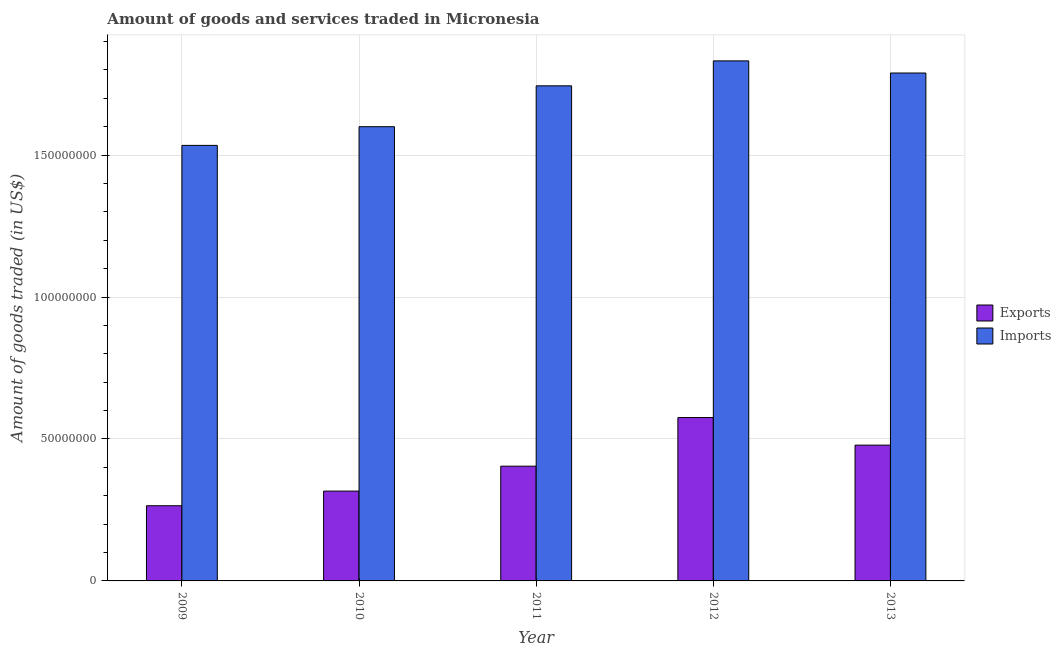Are the number of bars per tick equal to the number of legend labels?
Provide a short and direct response. Yes. Are the number of bars on each tick of the X-axis equal?
Offer a terse response. Yes. How many bars are there on the 5th tick from the left?
Provide a succinct answer. 2. How many bars are there on the 3rd tick from the right?
Provide a succinct answer. 2. What is the label of the 4th group of bars from the left?
Provide a succinct answer. 2012. What is the amount of goods imported in 2012?
Offer a terse response. 1.83e+08. Across all years, what is the maximum amount of goods imported?
Make the answer very short. 1.83e+08. Across all years, what is the minimum amount of goods exported?
Offer a very short reply. 2.65e+07. What is the total amount of goods imported in the graph?
Offer a very short reply. 8.50e+08. What is the difference between the amount of goods exported in 2011 and that in 2012?
Your answer should be very brief. -1.71e+07. What is the difference between the amount of goods exported in 2011 and the amount of goods imported in 2010?
Your answer should be compact. 8.78e+06. What is the average amount of goods exported per year?
Make the answer very short. 4.08e+07. In the year 2013, what is the difference between the amount of goods imported and amount of goods exported?
Offer a very short reply. 0. In how many years, is the amount of goods imported greater than 100000000 US$?
Ensure brevity in your answer.  5. What is the ratio of the amount of goods exported in 2009 to that in 2011?
Offer a terse response. 0.66. Is the amount of goods imported in 2012 less than that in 2013?
Your answer should be compact. No. Is the difference between the amount of goods exported in 2010 and 2011 greater than the difference between the amount of goods imported in 2010 and 2011?
Offer a very short reply. No. What is the difference between the highest and the second highest amount of goods imported?
Make the answer very short. 4.27e+06. What is the difference between the highest and the lowest amount of goods exported?
Offer a very short reply. 3.11e+07. Is the sum of the amount of goods imported in 2011 and 2013 greater than the maximum amount of goods exported across all years?
Ensure brevity in your answer.  Yes. What does the 2nd bar from the left in 2009 represents?
Your answer should be very brief. Imports. What does the 1st bar from the right in 2013 represents?
Offer a terse response. Imports. How many bars are there?
Provide a succinct answer. 10. How many years are there in the graph?
Give a very brief answer. 5. What is the difference between two consecutive major ticks on the Y-axis?
Give a very brief answer. 5.00e+07. Are the values on the major ticks of Y-axis written in scientific E-notation?
Provide a short and direct response. No. Does the graph contain any zero values?
Ensure brevity in your answer.  No. How are the legend labels stacked?
Provide a short and direct response. Vertical. What is the title of the graph?
Offer a terse response. Amount of goods and services traded in Micronesia. Does "Mobile cellular" appear as one of the legend labels in the graph?
Your answer should be very brief. No. What is the label or title of the X-axis?
Ensure brevity in your answer.  Year. What is the label or title of the Y-axis?
Offer a terse response. Amount of goods traded (in US$). What is the Amount of goods traded (in US$) in Exports in 2009?
Offer a very short reply. 2.65e+07. What is the Amount of goods traded (in US$) in Imports in 2009?
Offer a very short reply. 1.53e+08. What is the Amount of goods traded (in US$) of Exports in 2010?
Make the answer very short. 3.16e+07. What is the Amount of goods traded (in US$) of Imports in 2010?
Provide a short and direct response. 1.60e+08. What is the Amount of goods traded (in US$) of Exports in 2011?
Offer a very short reply. 4.04e+07. What is the Amount of goods traded (in US$) of Imports in 2011?
Give a very brief answer. 1.74e+08. What is the Amount of goods traded (in US$) of Exports in 2012?
Keep it short and to the point. 5.76e+07. What is the Amount of goods traded (in US$) in Imports in 2012?
Provide a short and direct response. 1.83e+08. What is the Amount of goods traded (in US$) in Exports in 2013?
Ensure brevity in your answer.  4.78e+07. What is the Amount of goods traded (in US$) of Imports in 2013?
Provide a short and direct response. 1.79e+08. Across all years, what is the maximum Amount of goods traded (in US$) of Exports?
Give a very brief answer. 5.76e+07. Across all years, what is the maximum Amount of goods traded (in US$) in Imports?
Ensure brevity in your answer.  1.83e+08. Across all years, what is the minimum Amount of goods traded (in US$) in Exports?
Offer a very short reply. 2.65e+07. Across all years, what is the minimum Amount of goods traded (in US$) of Imports?
Offer a very short reply. 1.53e+08. What is the total Amount of goods traded (in US$) in Exports in the graph?
Offer a terse response. 2.04e+08. What is the total Amount of goods traded (in US$) in Imports in the graph?
Provide a succinct answer. 8.50e+08. What is the difference between the Amount of goods traded (in US$) in Exports in 2009 and that in 2010?
Your answer should be very brief. -5.16e+06. What is the difference between the Amount of goods traded (in US$) in Imports in 2009 and that in 2010?
Provide a short and direct response. -6.59e+06. What is the difference between the Amount of goods traded (in US$) in Exports in 2009 and that in 2011?
Give a very brief answer. -1.39e+07. What is the difference between the Amount of goods traded (in US$) of Imports in 2009 and that in 2011?
Your answer should be very brief. -2.10e+07. What is the difference between the Amount of goods traded (in US$) in Exports in 2009 and that in 2012?
Ensure brevity in your answer.  -3.11e+07. What is the difference between the Amount of goods traded (in US$) of Imports in 2009 and that in 2012?
Make the answer very short. -2.98e+07. What is the difference between the Amount of goods traded (in US$) in Exports in 2009 and that in 2013?
Offer a terse response. -2.13e+07. What is the difference between the Amount of goods traded (in US$) in Imports in 2009 and that in 2013?
Ensure brevity in your answer.  -2.55e+07. What is the difference between the Amount of goods traded (in US$) in Exports in 2010 and that in 2011?
Provide a short and direct response. -8.78e+06. What is the difference between the Amount of goods traded (in US$) of Imports in 2010 and that in 2011?
Ensure brevity in your answer.  -1.44e+07. What is the difference between the Amount of goods traded (in US$) in Exports in 2010 and that in 2012?
Provide a succinct answer. -2.59e+07. What is the difference between the Amount of goods traded (in US$) in Imports in 2010 and that in 2012?
Keep it short and to the point. -2.32e+07. What is the difference between the Amount of goods traded (in US$) of Exports in 2010 and that in 2013?
Your answer should be compact. -1.62e+07. What is the difference between the Amount of goods traded (in US$) in Imports in 2010 and that in 2013?
Offer a very short reply. -1.89e+07. What is the difference between the Amount of goods traded (in US$) of Exports in 2011 and that in 2012?
Keep it short and to the point. -1.71e+07. What is the difference between the Amount of goods traded (in US$) of Imports in 2011 and that in 2012?
Your answer should be very brief. -8.79e+06. What is the difference between the Amount of goods traded (in US$) of Exports in 2011 and that in 2013?
Give a very brief answer. -7.41e+06. What is the difference between the Amount of goods traded (in US$) in Imports in 2011 and that in 2013?
Your answer should be compact. -4.51e+06. What is the difference between the Amount of goods traded (in US$) in Exports in 2012 and that in 2013?
Offer a very short reply. 9.72e+06. What is the difference between the Amount of goods traded (in US$) in Imports in 2012 and that in 2013?
Provide a short and direct response. 4.27e+06. What is the difference between the Amount of goods traded (in US$) in Exports in 2009 and the Amount of goods traded (in US$) in Imports in 2010?
Offer a terse response. -1.34e+08. What is the difference between the Amount of goods traded (in US$) of Exports in 2009 and the Amount of goods traded (in US$) of Imports in 2011?
Ensure brevity in your answer.  -1.48e+08. What is the difference between the Amount of goods traded (in US$) of Exports in 2009 and the Amount of goods traded (in US$) of Imports in 2012?
Your answer should be very brief. -1.57e+08. What is the difference between the Amount of goods traded (in US$) in Exports in 2009 and the Amount of goods traded (in US$) in Imports in 2013?
Your answer should be very brief. -1.52e+08. What is the difference between the Amount of goods traded (in US$) of Exports in 2010 and the Amount of goods traded (in US$) of Imports in 2011?
Give a very brief answer. -1.43e+08. What is the difference between the Amount of goods traded (in US$) of Exports in 2010 and the Amount of goods traded (in US$) of Imports in 2012?
Provide a short and direct response. -1.52e+08. What is the difference between the Amount of goods traded (in US$) of Exports in 2010 and the Amount of goods traded (in US$) of Imports in 2013?
Your response must be concise. -1.47e+08. What is the difference between the Amount of goods traded (in US$) in Exports in 2011 and the Amount of goods traded (in US$) in Imports in 2012?
Make the answer very short. -1.43e+08. What is the difference between the Amount of goods traded (in US$) in Exports in 2011 and the Amount of goods traded (in US$) in Imports in 2013?
Offer a very short reply. -1.39e+08. What is the difference between the Amount of goods traded (in US$) in Exports in 2012 and the Amount of goods traded (in US$) in Imports in 2013?
Ensure brevity in your answer.  -1.21e+08. What is the average Amount of goods traded (in US$) of Exports per year?
Your answer should be compact. 4.08e+07. What is the average Amount of goods traded (in US$) in Imports per year?
Give a very brief answer. 1.70e+08. In the year 2009, what is the difference between the Amount of goods traded (in US$) in Exports and Amount of goods traded (in US$) in Imports?
Provide a short and direct response. -1.27e+08. In the year 2010, what is the difference between the Amount of goods traded (in US$) of Exports and Amount of goods traded (in US$) of Imports?
Provide a short and direct response. -1.28e+08. In the year 2011, what is the difference between the Amount of goods traded (in US$) in Exports and Amount of goods traded (in US$) in Imports?
Offer a very short reply. -1.34e+08. In the year 2012, what is the difference between the Amount of goods traded (in US$) in Exports and Amount of goods traded (in US$) in Imports?
Your answer should be compact. -1.26e+08. In the year 2013, what is the difference between the Amount of goods traded (in US$) in Exports and Amount of goods traded (in US$) in Imports?
Offer a very short reply. -1.31e+08. What is the ratio of the Amount of goods traded (in US$) of Exports in 2009 to that in 2010?
Keep it short and to the point. 0.84. What is the ratio of the Amount of goods traded (in US$) of Imports in 2009 to that in 2010?
Offer a very short reply. 0.96. What is the ratio of the Amount of goods traded (in US$) of Exports in 2009 to that in 2011?
Give a very brief answer. 0.66. What is the ratio of the Amount of goods traded (in US$) in Imports in 2009 to that in 2011?
Your answer should be compact. 0.88. What is the ratio of the Amount of goods traded (in US$) of Exports in 2009 to that in 2012?
Make the answer very short. 0.46. What is the ratio of the Amount of goods traded (in US$) of Imports in 2009 to that in 2012?
Provide a short and direct response. 0.84. What is the ratio of the Amount of goods traded (in US$) of Exports in 2009 to that in 2013?
Your response must be concise. 0.55. What is the ratio of the Amount of goods traded (in US$) of Imports in 2009 to that in 2013?
Offer a very short reply. 0.86. What is the ratio of the Amount of goods traded (in US$) in Exports in 2010 to that in 2011?
Offer a very short reply. 0.78. What is the ratio of the Amount of goods traded (in US$) in Imports in 2010 to that in 2011?
Offer a terse response. 0.92. What is the ratio of the Amount of goods traded (in US$) in Exports in 2010 to that in 2012?
Make the answer very short. 0.55. What is the ratio of the Amount of goods traded (in US$) of Imports in 2010 to that in 2012?
Your response must be concise. 0.87. What is the ratio of the Amount of goods traded (in US$) in Exports in 2010 to that in 2013?
Ensure brevity in your answer.  0.66. What is the ratio of the Amount of goods traded (in US$) of Imports in 2010 to that in 2013?
Keep it short and to the point. 0.89. What is the ratio of the Amount of goods traded (in US$) of Exports in 2011 to that in 2012?
Ensure brevity in your answer.  0.7. What is the ratio of the Amount of goods traded (in US$) of Imports in 2011 to that in 2012?
Provide a short and direct response. 0.95. What is the ratio of the Amount of goods traded (in US$) in Exports in 2011 to that in 2013?
Keep it short and to the point. 0.84. What is the ratio of the Amount of goods traded (in US$) of Imports in 2011 to that in 2013?
Your answer should be very brief. 0.97. What is the ratio of the Amount of goods traded (in US$) of Exports in 2012 to that in 2013?
Offer a very short reply. 1.2. What is the ratio of the Amount of goods traded (in US$) in Imports in 2012 to that in 2013?
Give a very brief answer. 1.02. What is the difference between the highest and the second highest Amount of goods traded (in US$) of Exports?
Your answer should be compact. 9.72e+06. What is the difference between the highest and the second highest Amount of goods traded (in US$) of Imports?
Keep it short and to the point. 4.27e+06. What is the difference between the highest and the lowest Amount of goods traded (in US$) in Exports?
Your answer should be compact. 3.11e+07. What is the difference between the highest and the lowest Amount of goods traded (in US$) of Imports?
Make the answer very short. 2.98e+07. 